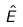<formula> <loc_0><loc_0><loc_500><loc_500>\hat { E }</formula> 